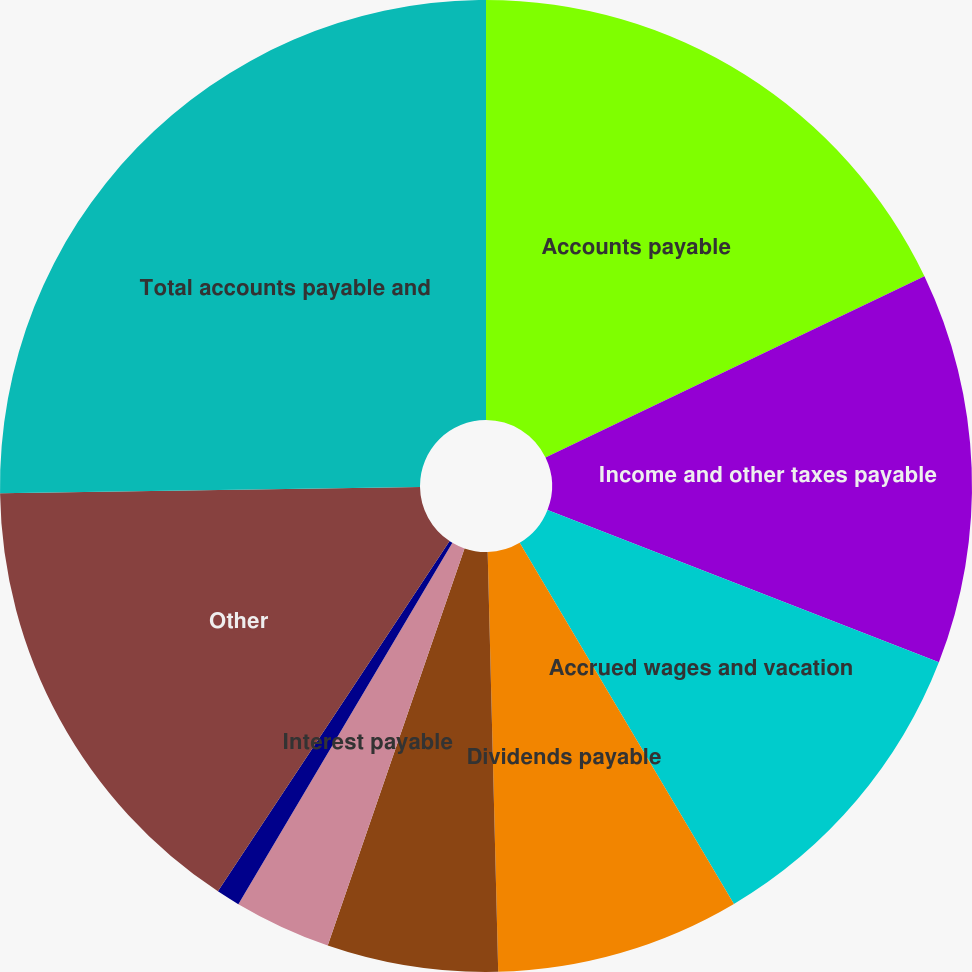Convert chart to OTSL. <chart><loc_0><loc_0><loc_500><loc_500><pie_chart><fcel>Accounts payable<fcel>Income and other taxes payable<fcel>Accrued wages and vacation<fcel>Dividends payable<fcel>Accrued casualty costs<fcel>Interest payable<fcel>Equipment rents payable<fcel>Other<fcel>Total accounts payable and<nl><fcel>17.9%<fcel>13.01%<fcel>10.57%<fcel>8.12%<fcel>5.68%<fcel>3.23%<fcel>0.79%<fcel>15.46%<fcel>25.24%<nl></chart> 